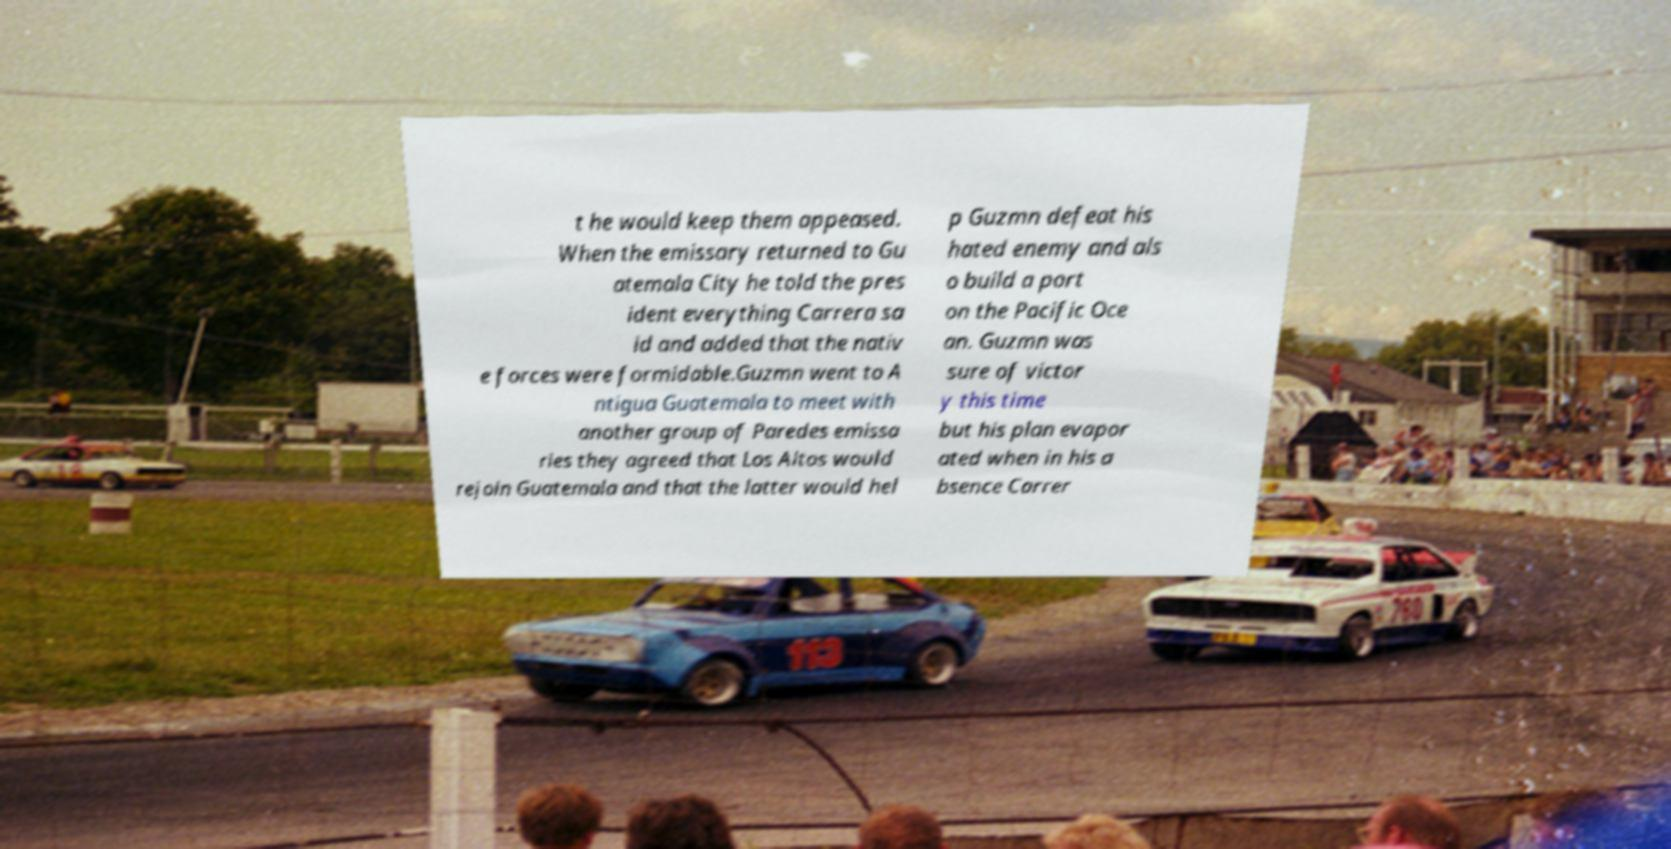Can you read and provide the text displayed in the image?This photo seems to have some interesting text. Can you extract and type it out for me? t he would keep them appeased. When the emissary returned to Gu atemala City he told the pres ident everything Carrera sa id and added that the nativ e forces were formidable.Guzmn went to A ntigua Guatemala to meet with another group of Paredes emissa ries they agreed that Los Altos would rejoin Guatemala and that the latter would hel p Guzmn defeat his hated enemy and als o build a port on the Pacific Oce an. Guzmn was sure of victor y this time but his plan evapor ated when in his a bsence Carrer 